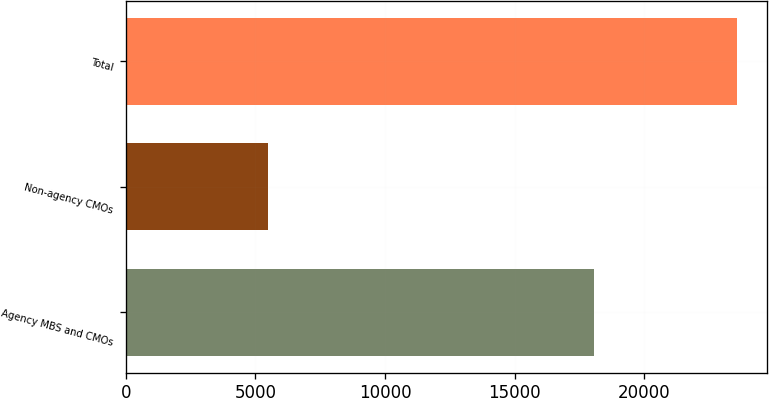<chart> <loc_0><loc_0><loc_500><loc_500><bar_chart><fcel>Agency MBS and CMOs<fcel>Non-agency CMOs<fcel>Total<nl><fcel>18062<fcel>5506<fcel>23568<nl></chart> 